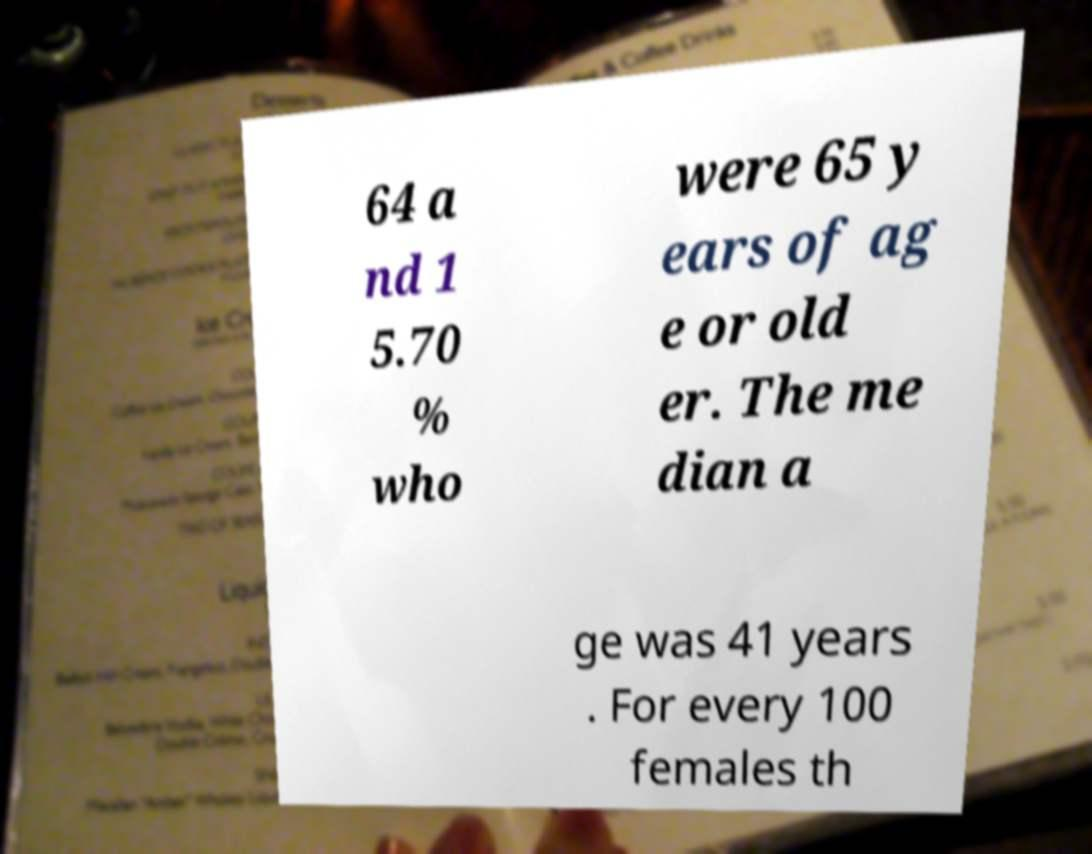Could you extract and type out the text from this image? 64 a nd 1 5.70 % who were 65 y ears of ag e or old er. The me dian a ge was 41 years . For every 100 females th 